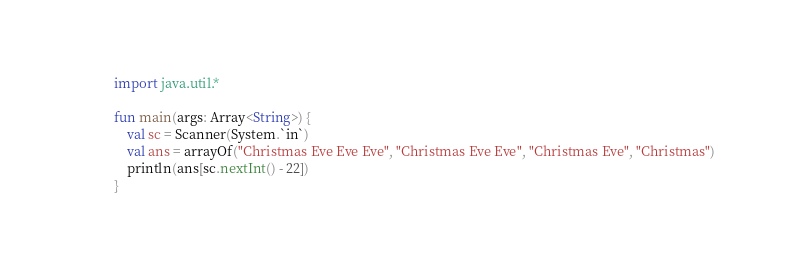<code> <loc_0><loc_0><loc_500><loc_500><_Kotlin_>import java.util.*

fun main(args: Array<String>) {
    val sc = Scanner(System.`in`)
    val ans = arrayOf("Christmas Eve Eve Eve", "Christmas Eve Eve", "Christmas Eve", "Christmas")
    println(ans[sc.nextInt() - 22])
}</code> 